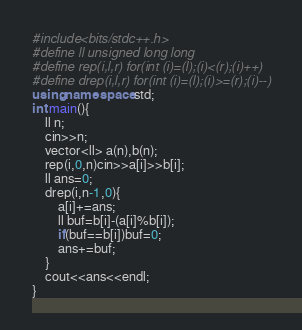Convert code to text. <code><loc_0><loc_0><loc_500><loc_500><_C++_>#include<bits/stdc++.h>
#define ll unsigned long long
#define rep(i,l,r) for(int (i)=(l);(i)<(r);(i)++)
#define drep(i,l,r) for(int (i)=(l);(i)>=(r);(i)--)
using namespace std;
int main(){
    ll n;
    cin>>n;
    vector<ll> a(n),b(n);
    rep(i,0,n)cin>>a[i]>>b[i];
    ll ans=0;
    drep(i,n-1,0){
        a[i]+=ans;
        ll buf=b[i]-(a[i]%b[i]);
        if(buf==b[i])buf=0;
        ans+=buf;
    }
    cout<<ans<<endl;
}</code> 